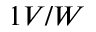<formula> <loc_0><loc_0><loc_500><loc_500>1 V / W</formula> 